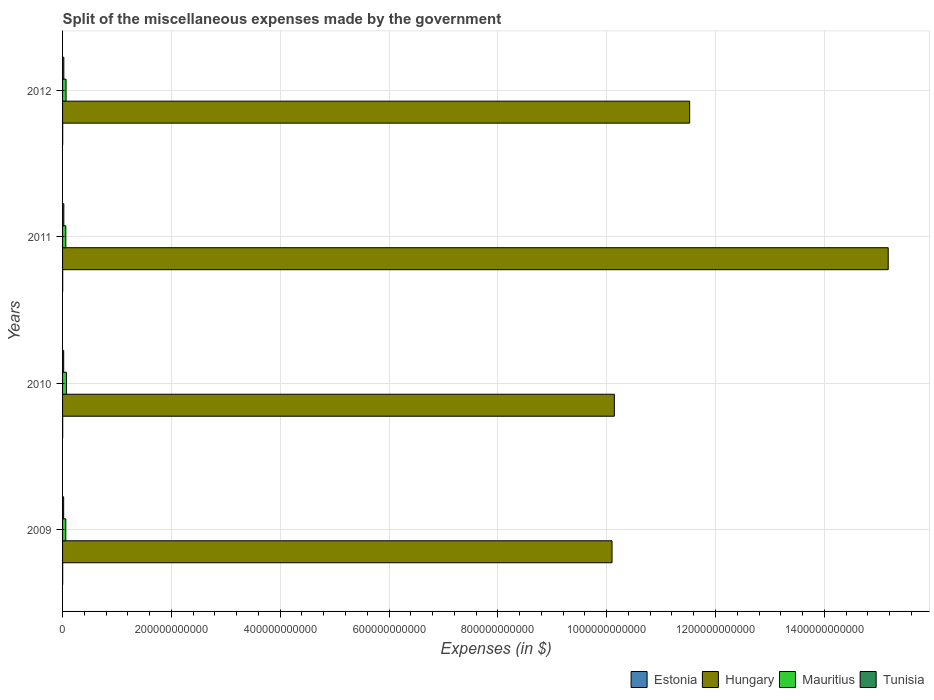Are the number of bars per tick equal to the number of legend labels?
Keep it short and to the point. Yes. How many bars are there on the 4th tick from the bottom?
Your answer should be compact. 4. What is the miscellaneous expenses made by the government in Estonia in 2011?
Your answer should be very brief. 2.22e+08. Across all years, what is the maximum miscellaneous expenses made by the government in Mauritius?
Give a very brief answer. 7.10e+09. Across all years, what is the minimum miscellaneous expenses made by the government in Estonia?
Keep it short and to the point. 1.95e+08. In which year was the miscellaneous expenses made by the government in Mauritius maximum?
Make the answer very short. 2010. In which year was the miscellaneous expenses made by the government in Hungary minimum?
Your response must be concise. 2009. What is the total miscellaneous expenses made by the government in Hungary in the graph?
Give a very brief answer. 4.69e+12. What is the difference between the miscellaneous expenses made by the government in Tunisia in 2010 and that in 2012?
Provide a succinct answer. -2.43e+08. What is the difference between the miscellaneous expenses made by the government in Tunisia in 2009 and the miscellaneous expenses made by the government in Hungary in 2011?
Keep it short and to the point. -1.52e+12. What is the average miscellaneous expenses made by the government in Mauritius per year?
Your answer should be very brief. 6.36e+09. In the year 2011, what is the difference between the miscellaneous expenses made by the government in Tunisia and miscellaneous expenses made by the government in Hungary?
Make the answer very short. -1.52e+12. In how many years, is the miscellaneous expenses made by the government in Tunisia greater than 1440000000000 $?
Offer a terse response. 0. What is the ratio of the miscellaneous expenses made by the government in Estonia in 2009 to that in 2010?
Your answer should be compact. 0.93. Is the miscellaneous expenses made by the government in Mauritius in 2009 less than that in 2011?
Give a very brief answer. Yes. What is the difference between the highest and the second highest miscellaneous expenses made by the government in Hungary?
Provide a short and direct response. 3.65e+11. What is the difference between the highest and the lowest miscellaneous expenses made by the government in Estonia?
Offer a very short reply. 5.91e+07. Is the sum of the miscellaneous expenses made by the government in Estonia in 2010 and 2011 greater than the maximum miscellaneous expenses made by the government in Hungary across all years?
Provide a succinct answer. No. Is it the case that in every year, the sum of the miscellaneous expenses made by the government in Tunisia and miscellaneous expenses made by the government in Mauritius is greater than the sum of miscellaneous expenses made by the government in Hungary and miscellaneous expenses made by the government in Estonia?
Your answer should be very brief. No. What does the 2nd bar from the top in 2010 represents?
Give a very brief answer. Mauritius. What does the 3rd bar from the bottom in 2011 represents?
Make the answer very short. Mauritius. Is it the case that in every year, the sum of the miscellaneous expenses made by the government in Hungary and miscellaneous expenses made by the government in Estonia is greater than the miscellaneous expenses made by the government in Tunisia?
Give a very brief answer. Yes. Are all the bars in the graph horizontal?
Your answer should be compact. Yes. What is the difference between two consecutive major ticks on the X-axis?
Offer a very short reply. 2.00e+11. Are the values on the major ticks of X-axis written in scientific E-notation?
Give a very brief answer. No. Does the graph contain grids?
Keep it short and to the point. Yes. How many legend labels are there?
Offer a very short reply. 4. How are the legend labels stacked?
Provide a short and direct response. Horizontal. What is the title of the graph?
Ensure brevity in your answer.  Split of the miscellaneous expenses made by the government. What is the label or title of the X-axis?
Ensure brevity in your answer.  Expenses (in $). What is the label or title of the Y-axis?
Keep it short and to the point. Years. What is the Expenses (in $) of Estonia in 2009?
Provide a short and direct response. 1.95e+08. What is the Expenses (in $) in Hungary in 2009?
Offer a very short reply. 1.01e+12. What is the Expenses (in $) of Mauritius in 2009?
Ensure brevity in your answer.  5.93e+09. What is the Expenses (in $) of Tunisia in 2009?
Your answer should be compact. 2.00e+09. What is the Expenses (in $) of Estonia in 2010?
Keep it short and to the point. 2.09e+08. What is the Expenses (in $) of Hungary in 2010?
Ensure brevity in your answer.  1.01e+12. What is the Expenses (in $) of Mauritius in 2010?
Ensure brevity in your answer.  7.10e+09. What is the Expenses (in $) of Tunisia in 2010?
Your answer should be very brief. 2.07e+09. What is the Expenses (in $) in Estonia in 2011?
Give a very brief answer. 2.22e+08. What is the Expenses (in $) of Hungary in 2011?
Your answer should be very brief. 1.52e+12. What is the Expenses (in $) in Mauritius in 2011?
Offer a very short reply. 5.98e+09. What is the Expenses (in $) of Tunisia in 2011?
Your answer should be very brief. 2.32e+09. What is the Expenses (in $) of Estonia in 2012?
Provide a succinct answer. 2.54e+08. What is the Expenses (in $) of Hungary in 2012?
Offer a terse response. 1.15e+12. What is the Expenses (in $) of Mauritius in 2012?
Your answer should be compact. 6.43e+09. What is the Expenses (in $) in Tunisia in 2012?
Your response must be concise. 2.32e+09. Across all years, what is the maximum Expenses (in $) in Estonia?
Your answer should be very brief. 2.54e+08. Across all years, what is the maximum Expenses (in $) of Hungary?
Offer a very short reply. 1.52e+12. Across all years, what is the maximum Expenses (in $) of Mauritius?
Provide a short and direct response. 7.10e+09. Across all years, what is the maximum Expenses (in $) in Tunisia?
Offer a very short reply. 2.32e+09. Across all years, what is the minimum Expenses (in $) in Estonia?
Your answer should be compact. 1.95e+08. Across all years, what is the minimum Expenses (in $) of Hungary?
Your answer should be compact. 1.01e+12. Across all years, what is the minimum Expenses (in $) in Mauritius?
Give a very brief answer. 5.93e+09. Across all years, what is the minimum Expenses (in $) of Tunisia?
Your answer should be very brief. 2.00e+09. What is the total Expenses (in $) of Estonia in the graph?
Ensure brevity in your answer.  8.81e+08. What is the total Expenses (in $) of Hungary in the graph?
Offer a very short reply. 4.69e+12. What is the total Expenses (in $) of Mauritius in the graph?
Your answer should be very brief. 2.54e+1. What is the total Expenses (in $) of Tunisia in the graph?
Provide a short and direct response. 8.72e+09. What is the difference between the Expenses (in $) of Estonia in 2009 and that in 2010?
Provide a short and direct response. -1.44e+07. What is the difference between the Expenses (in $) of Hungary in 2009 and that in 2010?
Offer a very short reply. -4.23e+09. What is the difference between the Expenses (in $) in Mauritius in 2009 and that in 2010?
Make the answer very short. -1.17e+09. What is the difference between the Expenses (in $) of Tunisia in 2009 and that in 2010?
Your response must be concise. -7.06e+07. What is the difference between the Expenses (in $) of Estonia in 2009 and that in 2011?
Offer a terse response. -2.76e+07. What is the difference between the Expenses (in $) in Hungary in 2009 and that in 2011?
Your response must be concise. -5.08e+11. What is the difference between the Expenses (in $) in Mauritius in 2009 and that in 2011?
Give a very brief answer. -4.98e+07. What is the difference between the Expenses (in $) in Tunisia in 2009 and that in 2011?
Offer a very short reply. -3.21e+08. What is the difference between the Expenses (in $) of Estonia in 2009 and that in 2012?
Offer a very short reply. -5.91e+07. What is the difference between the Expenses (in $) in Hungary in 2009 and that in 2012?
Your answer should be very brief. -1.43e+11. What is the difference between the Expenses (in $) of Mauritius in 2009 and that in 2012?
Offer a very short reply. -4.99e+08. What is the difference between the Expenses (in $) of Tunisia in 2009 and that in 2012?
Your response must be concise. -3.14e+08. What is the difference between the Expenses (in $) in Estonia in 2010 and that in 2011?
Your answer should be very brief. -1.32e+07. What is the difference between the Expenses (in $) in Hungary in 2010 and that in 2011?
Your answer should be very brief. -5.03e+11. What is the difference between the Expenses (in $) of Mauritius in 2010 and that in 2011?
Keep it short and to the point. 1.12e+09. What is the difference between the Expenses (in $) in Tunisia in 2010 and that in 2011?
Ensure brevity in your answer.  -2.50e+08. What is the difference between the Expenses (in $) in Estonia in 2010 and that in 2012?
Make the answer very short. -4.47e+07. What is the difference between the Expenses (in $) in Hungary in 2010 and that in 2012?
Your answer should be compact. -1.38e+11. What is the difference between the Expenses (in $) in Mauritius in 2010 and that in 2012?
Ensure brevity in your answer.  6.73e+08. What is the difference between the Expenses (in $) of Tunisia in 2010 and that in 2012?
Keep it short and to the point. -2.43e+08. What is the difference between the Expenses (in $) in Estonia in 2011 and that in 2012?
Give a very brief answer. -3.15e+07. What is the difference between the Expenses (in $) of Hungary in 2011 and that in 2012?
Give a very brief answer. 3.65e+11. What is the difference between the Expenses (in $) of Mauritius in 2011 and that in 2012?
Offer a terse response. -4.49e+08. What is the difference between the Expenses (in $) in Tunisia in 2011 and that in 2012?
Offer a terse response. 7.20e+06. What is the difference between the Expenses (in $) of Estonia in 2009 and the Expenses (in $) of Hungary in 2010?
Provide a short and direct response. -1.01e+12. What is the difference between the Expenses (in $) of Estonia in 2009 and the Expenses (in $) of Mauritius in 2010?
Make the answer very short. -6.91e+09. What is the difference between the Expenses (in $) in Estonia in 2009 and the Expenses (in $) in Tunisia in 2010?
Offer a very short reply. -1.88e+09. What is the difference between the Expenses (in $) in Hungary in 2009 and the Expenses (in $) in Mauritius in 2010?
Give a very brief answer. 1.00e+12. What is the difference between the Expenses (in $) in Hungary in 2009 and the Expenses (in $) in Tunisia in 2010?
Provide a succinct answer. 1.01e+12. What is the difference between the Expenses (in $) in Mauritius in 2009 and the Expenses (in $) in Tunisia in 2010?
Provide a short and direct response. 3.86e+09. What is the difference between the Expenses (in $) of Estonia in 2009 and the Expenses (in $) of Hungary in 2011?
Ensure brevity in your answer.  -1.52e+12. What is the difference between the Expenses (in $) of Estonia in 2009 and the Expenses (in $) of Mauritius in 2011?
Provide a short and direct response. -5.79e+09. What is the difference between the Expenses (in $) of Estonia in 2009 and the Expenses (in $) of Tunisia in 2011?
Your response must be concise. -2.13e+09. What is the difference between the Expenses (in $) of Hungary in 2009 and the Expenses (in $) of Mauritius in 2011?
Your answer should be compact. 1.00e+12. What is the difference between the Expenses (in $) in Hungary in 2009 and the Expenses (in $) in Tunisia in 2011?
Your response must be concise. 1.01e+12. What is the difference between the Expenses (in $) in Mauritius in 2009 and the Expenses (in $) in Tunisia in 2011?
Offer a terse response. 3.61e+09. What is the difference between the Expenses (in $) of Estonia in 2009 and the Expenses (in $) of Hungary in 2012?
Give a very brief answer. -1.15e+12. What is the difference between the Expenses (in $) in Estonia in 2009 and the Expenses (in $) in Mauritius in 2012?
Provide a succinct answer. -6.23e+09. What is the difference between the Expenses (in $) of Estonia in 2009 and the Expenses (in $) of Tunisia in 2012?
Make the answer very short. -2.12e+09. What is the difference between the Expenses (in $) of Hungary in 2009 and the Expenses (in $) of Mauritius in 2012?
Your answer should be very brief. 1.00e+12. What is the difference between the Expenses (in $) of Hungary in 2009 and the Expenses (in $) of Tunisia in 2012?
Keep it short and to the point. 1.01e+12. What is the difference between the Expenses (in $) of Mauritius in 2009 and the Expenses (in $) of Tunisia in 2012?
Offer a terse response. 3.61e+09. What is the difference between the Expenses (in $) in Estonia in 2010 and the Expenses (in $) in Hungary in 2011?
Provide a short and direct response. -1.52e+12. What is the difference between the Expenses (in $) in Estonia in 2010 and the Expenses (in $) in Mauritius in 2011?
Your response must be concise. -5.77e+09. What is the difference between the Expenses (in $) of Estonia in 2010 and the Expenses (in $) of Tunisia in 2011?
Make the answer very short. -2.12e+09. What is the difference between the Expenses (in $) in Hungary in 2010 and the Expenses (in $) in Mauritius in 2011?
Your answer should be very brief. 1.01e+12. What is the difference between the Expenses (in $) in Hungary in 2010 and the Expenses (in $) in Tunisia in 2011?
Your answer should be very brief. 1.01e+12. What is the difference between the Expenses (in $) in Mauritius in 2010 and the Expenses (in $) in Tunisia in 2011?
Provide a succinct answer. 4.78e+09. What is the difference between the Expenses (in $) in Estonia in 2010 and the Expenses (in $) in Hungary in 2012?
Your response must be concise. -1.15e+12. What is the difference between the Expenses (in $) of Estonia in 2010 and the Expenses (in $) of Mauritius in 2012?
Your answer should be compact. -6.22e+09. What is the difference between the Expenses (in $) in Estonia in 2010 and the Expenses (in $) in Tunisia in 2012?
Provide a succinct answer. -2.11e+09. What is the difference between the Expenses (in $) of Hungary in 2010 and the Expenses (in $) of Mauritius in 2012?
Make the answer very short. 1.01e+12. What is the difference between the Expenses (in $) of Hungary in 2010 and the Expenses (in $) of Tunisia in 2012?
Your response must be concise. 1.01e+12. What is the difference between the Expenses (in $) in Mauritius in 2010 and the Expenses (in $) in Tunisia in 2012?
Your answer should be very brief. 4.79e+09. What is the difference between the Expenses (in $) of Estonia in 2011 and the Expenses (in $) of Hungary in 2012?
Offer a terse response. -1.15e+12. What is the difference between the Expenses (in $) in Estonia in 2011 and the Expenses (in $) in Mauritius in 2012?
Provide a short and direct response. -6.21e+09. What is the difference between the Expenses (in $) of Estonia in 2011 and the Expenses (in $) of Tunisia in 2012?
Provide a succinct answer. -2.10e+09. What is the difference between the Expenses (in $) of Hungary in 2011 and the Expenses (in $) of Mauritius in 2012?
Your answer should be compact. 1.51e+12. What is the difference between the Expenses (in $) of Hungary in 2011 and the Expenses (in $) of Tunisia in 2012?
Provide a succinct answer. 1.52e+12. What is the difference between the Expenses (in $) of Mauritius in 2011 and the Expenses (in $) of Tunisia in 2012?
Make the answer very short. 3.66e+09. What is the average Expenses (in $) in Estonia per year?
Keep it short and to the point. 2.20e+08. What is the average Expenses (in $) of Hungary per year?
Provide a short and direct response. 1.17e+12. What is the average Expenses (in $) in Mauritius per year?
Provide a short and direct response. 6.36e+09. What is the average Expenses (in $) of Tunisia per year?
Offer a terse response. 2.18e+09. In the year 2009, what is the difference between the Expenses (in $) in Estonia and Expenses (in $) in Hungary?
Provide a succinct answer. -1.01e+12. In the year 2009, what is the difference between the Expenses (in $) of Estonia and Expenses (in $) of Mauritius?
Make the answer very short. -5.74e+09. In the year 2009, what is the difference between the Expenses (in $) in Estonia and Expenses (in $) in Tunisia?
Your response must be concise. -1.81e+09. In the year 2009, what is the difference between the Expenses (in $) of Hungary and Expenses (in $) of Mauritius?
Provide a succinct answer. 1.00e+12. In the year 2009, what is the difference between the Expenses (in $) in Hungary and Expenses (in $) in Tunisia?
Your answer should be compact. 1.01e+12. In the year 2009, what is the difference between the Expenses (in $) in Mauritius and Expenses (in $) in Tunisia?
Keep it short and to the point. 3.93e+09. In the year 2010, what is the difference between the Expenses (in $) in Estonia and Expenses (in $) in Hungary?
Your response must be concise. -1.01e+12. In the year 2010, what is the difference between the Expenses (in $) in Estonia and Expenses (in $) in Mauritius?
Your answer should be compact. -6.89e+09. In the year 2010, what is the difference between the Expenses (in $) in Estonia and Expenses (in $) in Tunisia?
Your response must be concise. -1.87e+09. In the year 2010, what is the difference between the Expenses (in $) of Hungary and Expenses (in $) of Mauritius?
Your answer should be very brief. 1.01e+12. In the year 2010, what is the difference between the Expenses (in $) of Hungary and Expenses (in $) of Tunisia?
Offer a terse response. 1.01e+12. In the year 2010, what is the difference between the Expenses (in $) of Mauritius and Expenses (in $) of Tunisia?
Your response must be concise. 5.03e+09. In the year 2011, what is the difference between the Expenses (in $) in Estonia and Expenses (in $) in Hungary?
Your answer should be compact. -1.52e+12. In the year 2011, what is the difference between the Expenses (in $) in Estonia and Expenses (in $) in Mauritius?
Ensure brevity in your answer.  -5.76e+09. In the year 2011, what is the difference between the Expenses (in $) of Estonia and Expenses (in $) of Tunisia?
Provide a succinct answer. -2.10e+09. In the year 2011, what is the difference between the Expenses (in $) of Hungary and Expenses (in $) of Mauritius?
Your answer should be very brief. 1.51e+12. In the year 2011, what is the difference between the Expenses (in $) of Hungary and Expenses (in $) of Tunisia?
Provide a succinct answer. 1.52e+12. In the year 2011, what is the difference between the Expenses (in $) in Mauritius and Expenses (in $) in Tunisia?
Make the answer very short. 3.66e+09. In the year 2012, what is the difference between the Expenses (in $) of Estonia and Expenses (in $) of Hungary?
Provide a short and direct response. -1.15e+12. In the year 2012, what is the difference between the Expenses (in $) of Estonia and Expenses (in $) of Mauritius?
Offer a terse response. -6.18e+09. In the year 2012, what is the difference between the Expenses (in $) of Estonia and Expenses (in $) of Tunisia?
Offer a very short reply. -2.06e+09. In the year 2012, what is the difference between the Expenses (in $) in Hungary and Expenses (in $) in Mauritius?
Provide a short and direct response. 1.15e+12. In the year 2012, what is the difference between the Expenses (in $) in Hungary and Expenses (in $) in Tunisia?
Provide a short and direct response. 1.15e+12. In the year 2012, what is the difference between the Expenses (in $) in Mauritius and Expenses (in $) in Tunisia?
Keep it short and to the point. 4.11e+09. What is the ratio of the Expenses (in $) in Estonia in 2009 to that in 2010?
Your answer should be compact. 0.93. What is the ratio of the Expenses (in $) in Mauritius in 2009 to that in 2010?
Make the answer very short. 0.83. What is the ratio of the Expenses (in $) of Estonia in 2009 to that in 2011?
Keep it short and to the point. 0.88. What is the ratio of the Expenses (in $) in Hungary in 2009 to that in 2011?
Your answer should be very brief. 0.67. What is the ratio of the Expenses (in $) of Mauritius in 2009 to that in 2011?
Keep it short and to the point. 0.99. What is the ratio of the Expenses (in $) of Tunisia in 2009 to that in 2011?
Ensure brevity in your answer.  0.86. What is the ratio of the Expenses (in $) of Estonia in 2009 to that in 2012?
Give a very brief answer. 0.77. What is the ratio of the Expenses (in $) of Hungary in 2009 to that in 2012?
Your response must be concise. 0.88. What is the ratio of the Expenses (in $) of Mauritius in 2009 to that in 2012?
Provide a short and direct response. 0.92. What is the ratio of the Expenses (in $) in Tunisia in 2009 to that in 2012?
Your answer should be very brief. 0.86. What is the ratio of the Expenses (in $) of Estonia in 2010 to that in 2011?
Make the answer very short. 0.94. What is the ratio of the Expenses (in $) of Hungary in 2010 to that in 2011?
Your answer should be very brief. 0.67. What is the ratio of the Expenses (in $) of Mauritius in 2010 to that in 2011?
Your answer should be very brief. 1.19. What is the ratio of the Expenses (in $) of Tunisia in 2010 to that in 2011?
Keep it short and to the point. 0.89. What is the ratio of the Expenses (in $) in Estonia in 2010 to that in 2012?
Provide a short and direct response. 0.82. What is the ratio of the Expenses (in $) in Hungary in 2010 to that in 2012?
Offer a terse response. 0.88. What is the ratio of the Expenses (in $) of Mauritius in 2010 to that in 2012?
Provide a succinct answer. 1.1. What is the ratio of the Expenses (in $) in Tunisia in 2010 to that in 2012?
Offer a very short reply. 0.9. What is the ratio of the Expenses (in $) in Estonia in 2011 to that in 2012?
Provide a succinct answer. 0.88. What is the ratio of the Expenses (in $) of Hungary in 2011 to that in 2012?
Offer a terse response. 1.32. What is the ratio of the Expenses (in $) in Mauritius in 2011 to that in 2012?
Make the answer very short. 0.93. What is the ratio of the Expenses (in $) in Tunisia in 2011 to that in 2012?
Provide a succinct answer. 1. What is the difference between the highest and the second highest Expenses (in $) of Estonia?
Your answer should be compact. 3.15e+07. What is the difference between the highest and the second highest Expenses (in $) of Hungary?
Your answer should be compact. 3.65e+11. What is the difference between the highest and the second highest Expenses (in $) of Mauritius?
Keep it short and to the point. 6.73e+08. What is the difference between the highest and the second highest Expenses (in $) of Tunisia?
Your answer should be very brief. 7.20e+06. What is the difference between the highest and the lowest Expenses (in $) in Estonia?
Your answer should be compact. 5.91e+07. What is the difference between the highest and the lowest Expenses (in $) in Hungary?
Your answer should be compact. 5.08e+11. What is the difference between the highest and the lowest Expenses (in $) of Mauritius?
Keep it short and to the point. 1.17e+09. What is the difference between the highest and the lowest Expenses (in $) in Tunisia?
Offer a very short reply. 3.21e+08. 